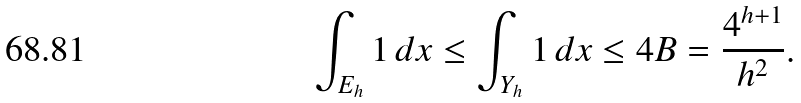Convert formula to latex. <formula><loc_0><loc_0><loc_500><loc_500>\int _ { E _ { h } } 1 \, d x \leq \int _ { Y _ { h } } 1 \, d x \leq 4 B = \frac { 4 ^ { h + 1 } } { h ^ { 2 } } .</formula> 